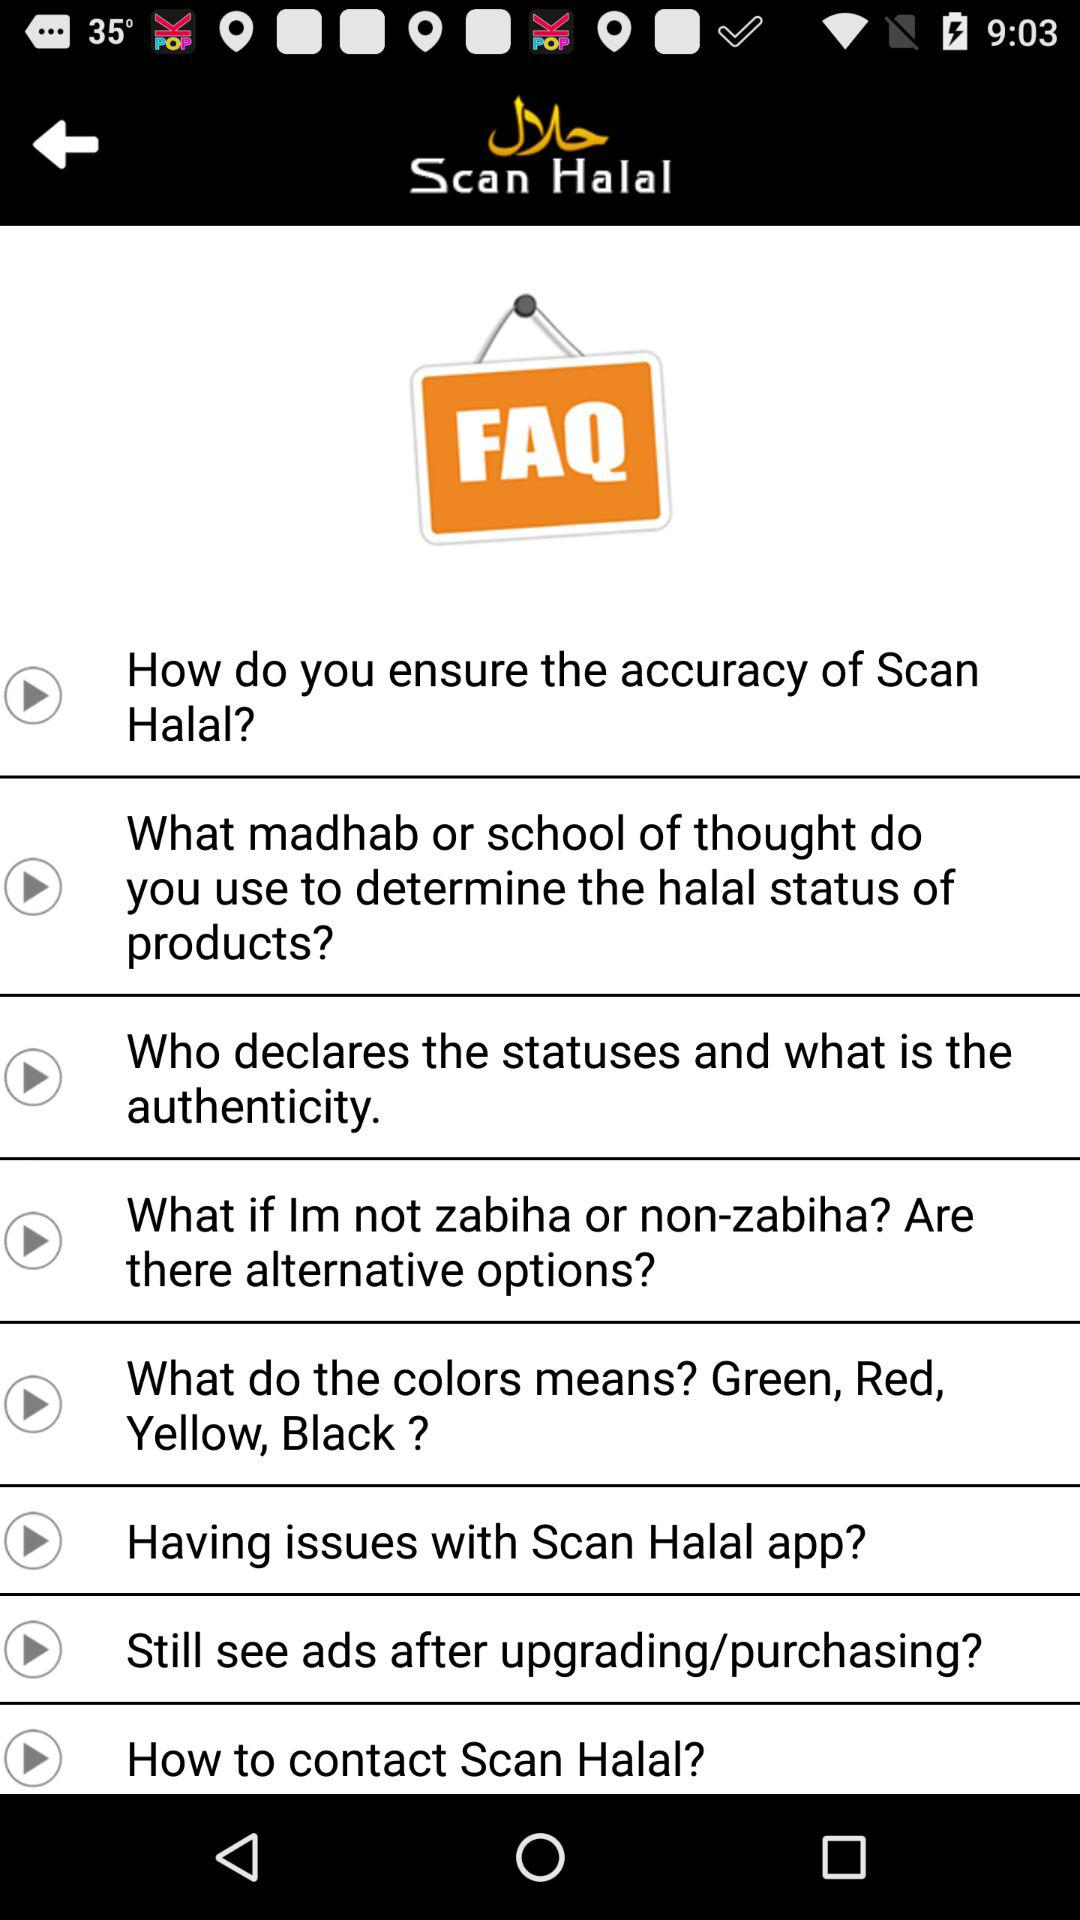What are the FAQs? The FAQs are "How do you ensure the accuracy of Scan Halal?", "What madhab or school of thought do you use to determine the halal status of products?", "Who declares the statuses and what is the authenticity.", "What if Im not zabiha or non-zabiha? Are there alternative options?", "What do the colors means? Green, Red, Yellow, Black?", "Having issues with Scan Halal app?", "Still see ads after upgrading/purchasing?" and "How to contact Scan Halal?". 